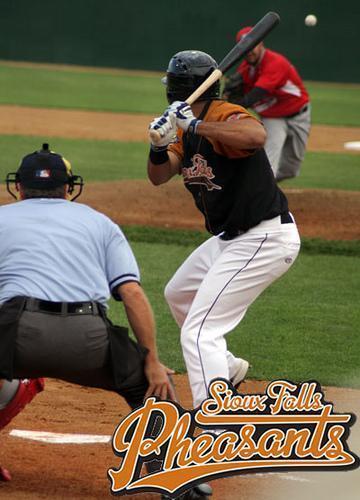How many people are playing football?
Give a very brief answer. 0. 